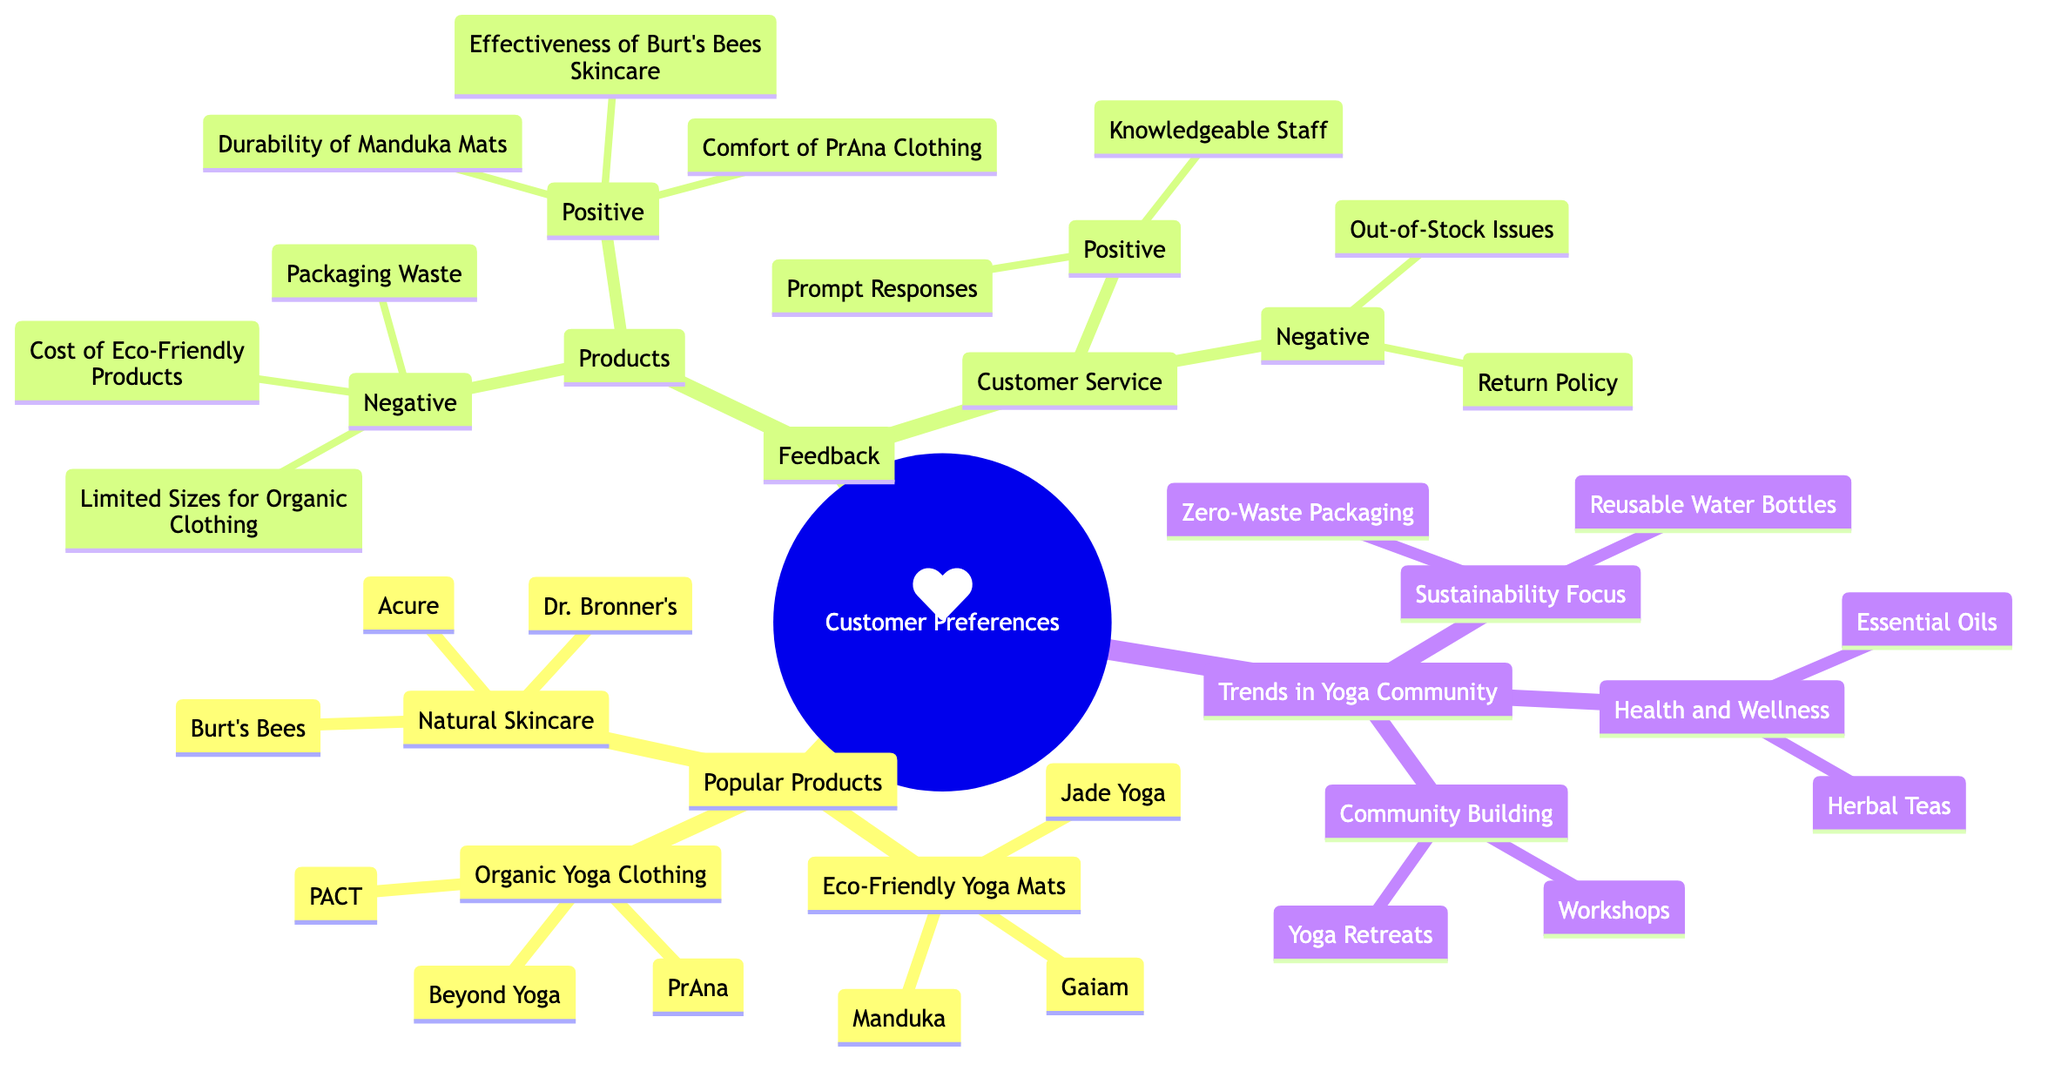What are the three popular product categories? The diagram outlines three main categories under "Popular Products": Eco-Friendly Yoga Mats, Organic Yoga Clothing, and Natural Skincare.
Answer: Eco-Friendly Yoga Mats, Organic Yoga Clothing, Natural Skincare Which brand is listed under Organic Yoga Clothing? The diagram specifies three brands under the Organic Yoga Clothing category: PrAna, Beyond Yoga, and PACT. Choosing one of these brands as an answer satisfies the inquiry.
Answer: PrAna What product received positive feedback for its durability? The diagram indicates that the Manduka Mats are praised specifically for their durability under the "Products" feedback section.
Answer: Durability of Manduka Mats How many brands are listed under Natural Skincare? The diagram shows three brands under the Natural Skincare category: Burt's Bees, Acure, and Dr. Bronner's. Therefore, the total count is three.
Answer: 3 What trend in the yoga community emphasizes waste reduction? "Sustainability Focus" is the trend mentioned in the diagram that emphasizes waste reduction, specifically mentioning "Zero-Waste Packaging."
Answer: Sustainability Focus Which type of products received negative feedback regarding cost? Referring to the negative feedback under "Products," the eco-friendly products received negative comments regarding cost, indicating they may be perceived as expensive.
Answer: Eco-Friendly Products What are two elements mentioned under "Health and Wellness"? The diagram lists Essential Oils and Herbal Teas as elements under the "Health and Wellness" trend, directly citing them as key components.
Answer: Essential Oils, Herbal Teas How many positive feedback items are mentioned for Customer Service? The feedback section for Customer Service includes two positive items: Prompt Responses and Knowledgeable Staff, totaling two instances of positive feedback.
Answer: 2 